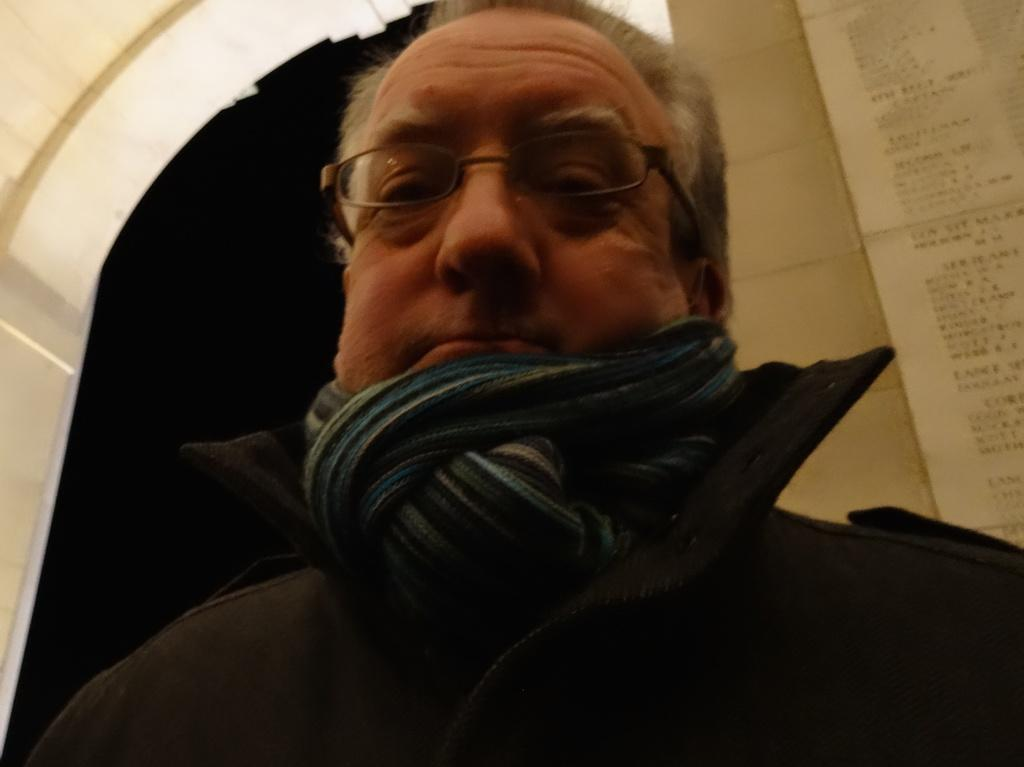Who is present in the image? There is a man in the image. What is the man wearing on his face? The man is wearing spectacles. What is the man wearing around his neck? The man is wearing a scarf. What can be seen in the background of the image? There is an arch and a wall with text in the background of the image. How would you describe the lighting in the image? The background of the image is dark. What type of fly is sitting on the man's shoulder in the image? There is no fly present on the man's shoulder in the image. What type of throne is the man sitting on in the image? There is no throne present in the image; the man is standing. 